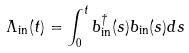<formula> <loc_0><loc_0><loc_500><loc_500>\Lambda _ { \text {in} } ( t ) = \int _ { 0 } ^ { t } b ^ { \dagger } _ { \text {in} } ( s ) b _ { \text {in} } ( s ) d s</formula> 